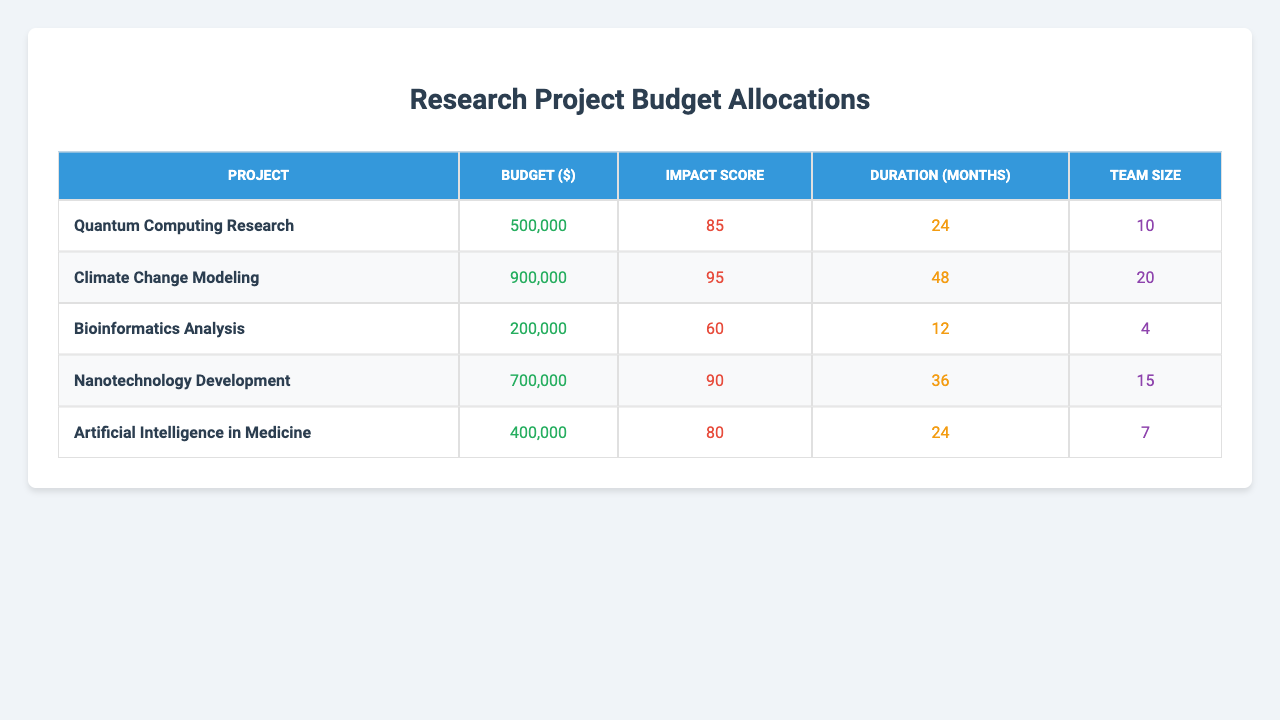What is the budget allocation for the "Artificial Intelligence in Medicine" project? The budget allocation for the "Artificial Intelligence in Medicine" project is located in the table under the corresponding project name. It shows a value of $400,000.
Answer: $400,000 Which project has the highest impact score? By examining the impact scores for each project, the highest score is 95, which corresponds to the "Climate Change Modeling" project.
Answer: "Climate Change Modeling" What is the average duration of all projects combined? To find the average duration, sum the durations: (24 + 36 + 18 + 30 + 24) = 132 months. Then divide by the number of projects (5): 132 / 5 = 26.4 months.
Answer: 26.4 months What is the budget difference between "Quantum Computing Research" and "Bioinformatics Analysis"? The budget for "Quantum Computing Research" is $500,000 and for "Bioinformatics Analysis" is $200,000. The difference is calculated as $500,000 - $200,000 = $300,000.
Answer: $300,000 Which project has the smallest team size? The smallest team size can be determined by reviewing the team sizes listed in the table. "Bioinformatics Analysis" has a team size of 4, which is the lowest.
Answer: 4 How many projects have a budget of over $600,000? Looking at the budget allocations, the projects exceeding $600,000 are "Quantum Computing Research," "Climate Change Modeling," "Nanotechnology Development," and "Artificial Intelligence in Medicine" totaling 4 projects.
Answer: 4 Is the impact score of the "Nanotechnology Development" project greater than the average impact score of all projects? The average impact score is calculated by summing the scores (85 + 90 + 70 + 88 + 82 = 415) which gives an average of 83. The score for "Nanotechnology Development" is 72, which is less than 83. Hence, the statement is false.
Answer: No What is the total budget allocated for all projects? Sum all budget allocations: $500,000 + $750,000 + $300,000 + $600,000 + $450,000 = $2,600,000.
Answer: $2,600,000 Which project has the longest duration overall and what is that duration? Reviewing the duration values, the project with the longest duration is "Climate Change Modeling" at 48 months.
Answer: "Climate Change Modeling," 48 months What is the average impact score of the projects with budgets below $500,000? "Bioinformatics Analysis" ($200,000) is the only project with a budget below $500,000 and its impact score is 60. Hence the average is 60/1 = 60.
Answer: 60 